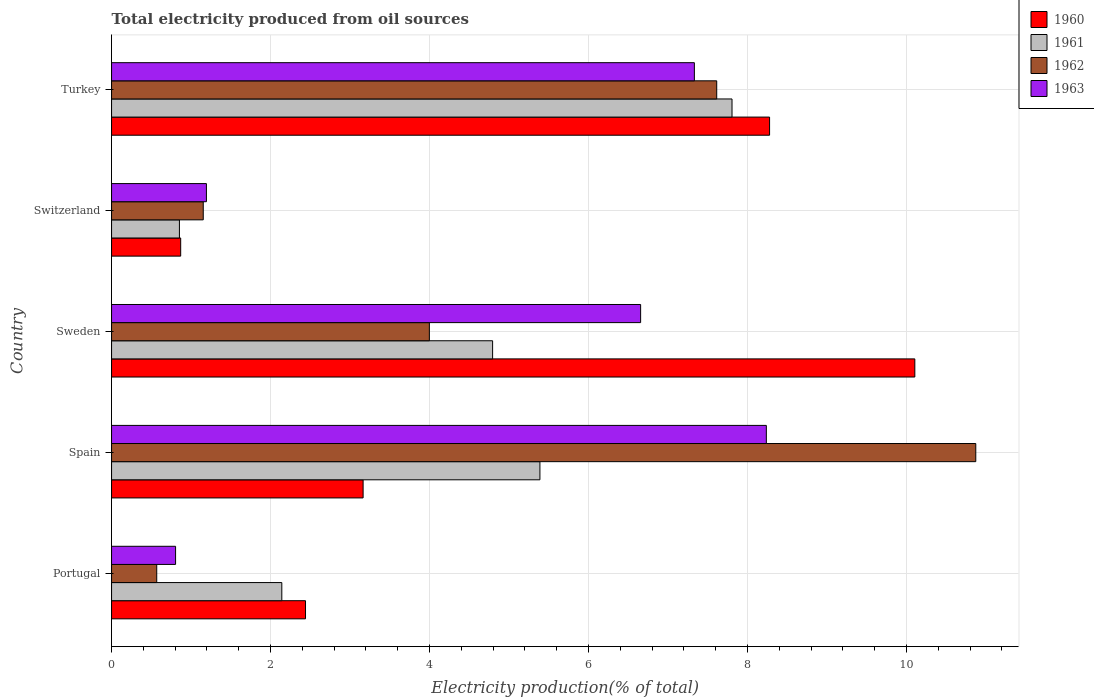How many different coloured bars are there?
Your answer should be compact. 4. Are the number of bars on each tick of the Y-axis equal?
Your answer should be compact. Yes. How many bars are there on the 5th tick from the top?
Your response must be concise. 4. What is the label of the 5th group of bars from the top?
Offer a very short reply. Portugal. In how many cases, is the number of bars for a given country not equal to the number of legend labels?
Provide a succinct answer. 0. What is the total electricity produced in 1961 in Spain?
Make the answer very short. 5.39. Across all countries, what is the maximum total electricity produced in 1963?
Ensure brevity in your answer.  8.24. Across all countries, what is the minimum total electricity produced in 1960?
Provide a short and direct response. 0.87. In which country was the total electricity produced in 1961 minimum?
Your answer should be compact. Switzerland. What is the total total electricity produced in 1963 in the graph?
Provide a short and direct response. 24.22. What is the difference between the total electricity produced in 1963 in Spain and that in Switzerland?
Give a very brief answer. 7.04. What is the difference between the total electricity produced in 1960 in Portugal and the total electricity produced in 1961 in Turkey?
Provide a short and direct response. -5.36. What is the average total electricity produced in 1960 per country?
Provide a succinct answer. 4.97. What is the difference between the total electricity produced in 1960 and total electricity produced in 1962 in Portugal?
Your answer should be very brief. 1.87. In how many countries, is the total electricity produced in 1960 greater than 5.6 %?
Your response must be concise. 2. What is the ratio of the total electricity produced in 1960 in Spain to that in Turkey?
Offer a very short reply. 0.38. Is the difference between the total electricity produced in 1960 in Spain and Switzerland greater than the difference between the total electricity produced in 1962 in Spain and Switzerland?
Your response must be concise. No. What is the difference between the highest and the second highest total electricity produced in 1960?
Provide a succinct answer. 1.83. What is the difference between the highest and the lowest total electricity produced in 1963?
Keep it short and to the point. 7.43. In how many countries, is the total electricity produced in 1960 greater than the average total electricity produced in 1960 taken over all countries?
Your answer should be compact. 2. Is the sum of the total electricity produced in 1961 in Spain and Turkey greater than the maximum total electricity produced in 1962 across all countries?
Your answer should be compact. Yes. What does the 3rd bar from the top in Spain represents?
Offer a terse response. 1961. What does the 1st bar from the bottom in Turkey represents?
Give a very brief answer. 1960. Are all the bars in the graph horizontal?
Make the answer very short. Yes. How many countries are there in the graph?
Offer a very short reply. 5. Where does the legend appear in the graph?
Give a very brief answer. Top right. What is the title of the graph?
Your answer should be compact. Total electricity produced from oil sources. What is the label or title of the X-axis?
Keep it short and to the point. Electricity production(% of total). What is the label or title of the Y-axis?
Offer a very short reply. Country. What is the Electricity production(% of total) of 1960 in Portugal?
Provide a short and direct response. 2.44. What is the Electricity production(% of total) in 1961 in Portugal?
Your answer should be very brief. 2.14. What is the Electricity production(% of total) in 1962 in Portugal?
Give a very brief answer. 0.57. What is the Electricity production(% of total) in 1963 in Portugal?
Offer a very short reply. 0.81. What is the Electricity production(% of total) in 1960 in Spain?
Provide a succinct answer. 3.16. What is the Electricity production(% of total) of 1961 in Spain?
Provide a succinct answer. 5.39. What is the Electricity production(% of total) of 1962 in Spain?
Provide a succinct answer. 10.87. What is the Electricity production(% of total) in 1963 in Spain?
Provide a short and direct response. 8.24. What is the Electricity production(% of total) in 1960 in Sweden?
Offer a very short reply. 10.1. What is the Electricity production(% of total) in 1961 in Sweden?
Your answer should be very brief. 4.79. What is the Electricity production(% of total) in 1962 in Sweden?
Offer a terse response. 4. What is the Electricity production(% of total) in 1963 in Sweden?
Give a very brief answer. 6.66. What is the Electricity production(% of total) in 1960 in Switzerland?
Your response must be concise. 0.87. What is the Electricity production(% of total) of 1961 in Switzerland?
Your response must be concise. 0.85. What is the Electricity production(% of total) of 1962 in Switzerland?
Provide a short and direct response. 1.15. What is the Electricity production(% of total) of 1963 in Switzerland?
Ensure brevity in your answer.  1.19. What is the Electricity production(% of total) in 1960 in Turkey?
Provide a short and direct response. 8.28. What is the Electricity production(% of total) in 1961 in Turkey?
Your answer should be very brief. 7.8. What is the Electricity production(% of total) in 1962 in Turkey?
Your answer should be compact. 7.61. What is the Electricity production(% of total) in 1963 in Turkey?
Keep it short and to the point. 7.33. Across all countries, what is the maximum Electricity production(% of total) in 1960?
Ensure brevity in your answer.  10.1. Across all countries, what is the maximum Electricity production(% of total) of 1961?
Offer a terse response. 7.8. Across all countries, what is the maximum Electricity production(% of total) in 1962?
Offer a terse response. 10.87. Across all countries, what is the maximum Electricity production(% of total) of 1963?
Provide a short and direct response. 8.24. Across all countries, what is the minimum Electricity production(% of total) in 1960?
Ensure brevity in your answer.  0.87. Across all countries, what is the minimum Electricity production(% of total) of 1961?
Your response must be concise. 0.85. Across all countries, what is the minimum Electricity production(% of total) in 1962?
Give a very brief answer. 0.57. Across all countries, what is the minimum Electricity production(% of total) of 1963?
Your answer should be compact. 0.81. What is the total Electricity production(% of total) in 1960 in the graph?
Provide a succinct answer. 24.85. What is the total Electricity production(% of total) of 1961 in the graph?
Ensure brevity in your answer.  20.98. What is the total Electricity production(% of total) in 1962 in the graph?
Your answer should be compact. 24.2. What is the total Electricity production(% of total) in 1963 in the graph?
Your response must be concise. 24.22. What is the difference between the Electricity production(% of total) of 1960 in Portugal and that in Spain?
Offer a very short reply. -0.72. What is the difference between the Electricity production(% of total) of 1961 in Portugal and that in Spain?
Ensure brevity in your answer.  -3.25. What is the difference between the Electricity production(% of total) in 1962 in Portugal and that in Spain?
Your response must be concise. -10.3. What is the difference between the Electricity production(% of total) of 1963 in Portugal and that in Spain?
Your answer should be very brief. -7.43. What is the difference between the Electricity production(% of total) of 1960 in Portugal and that in Sweden?
Provide a short and direct response. -7.66. What is the difference between the Electricity production(% of total) in 1961 in Portugal and that in Sweden?
Give a very brief answer. -2.65. What is the difference between the Electricity production(% of total) of 1962 in Portugal and that in Sweden?
Offer a terse response. -3.43. What is the difference between the Electricity production(% of total) of 1963 in Portugal and that in Sweden?
Provide a short and direct response. -5.85. What is the difference between the Electricity production(% of total) in 1960 in Portugal and that in Switzerland?
Give a very brief answer. 1.57. What is the difference between the Electricity production(% of total) of 1961 in Portugal and that in Switzerland?
Keep it short and to the point. 1.29. What is the difference between the Electricity production(% of total) in 1962 in Portugal and that in Switzerland?
Make the answer very short. -0.59. What is the difference between the Electricity production(% of total) of 1963 in Portugal and that in Switzerland?
Keep it short and to the point. -0.39. What is the difference between the Electricity production(% of total) in 1960 in Portugal and that in Turkey?
Your answer should be compact. -5.84. What is the difference between the Electricity production(% of total) of 1961 in Portugal and that in Turkey?
Your response must be concise. -5.66. What is the difference between the Electricity production(% of total) of 1962 in Portugal and that in Turkey?
Give a very brief answer. -7.04. What is the difference between the Electricity production(% of total) in 1963 in Portugal and that in Turkey?
Provide a succinct answer. -6.53. What is the difference between the Electricity production(% of total) of 1960 in Spain and that in Sweden?
Offer a terse response. -6.94. What is the difference between the Electricity production(% of total) in 1961 in Spain and that in Sweden?
Your response must be concise. 0.6. What is the difference between the Electricity production(% of total) in 1962 in Spain and that in Sweden?
Keep it short and to the point. 6.87. What is the difference between the Electricity production(% of total) of 1963 in Spain and that in Sweden?
Provide a short and direct response. 1.58. What is the difference between the Electricity production(% of total) in 1960 in Spain and that in Switzerland?
Your answer should be very brief. 2.29. What is the difference between the Electricity production(% of total) of 1961 in Spain and that in Switzerland?
Your answer should be very brief. 4.53. What is the difference between the Electricity production(% of total) of 1962 in Spain and that in Switzerland?
Give a very brief answer. 9.72. What is the difference between the Electricity production(% of total) in 1963 in Spain and that in Switzerland?
Provide a short and direct response. 7.04. What is the difference between the Electricity production(% of total) of 1960 in Spain and that in Turkey?
Keep it short and to the point. -5.11. What is the difference between the Electricity production(% of total) of 1961 in Spain and that in Turkey?
Offer a terse response. -2.42. What is the difference between the Electricity production(% of total) in 1962 in Spain and that in Turkey?
Offer a very short reply. 3.26. What is the difference between the Electricity production(% of total) of 1963 in Spain and that in Turkey?
Your answer should be compact. 0.91. What is the difference between the Electricity production(% of total) of 1960 in Sweden and that in Switzerland?
Provide a short and direct response. 9.23. What is the difference between the Electricity production(% of total) of 1961 in Sweden and that in Switzerland?
Offer a very short reply. 3.94. What is the difference between the Electricity production(% of total) of 1962 in Sweden and that in Switzerland?
Provide a succinct answer. 2.84. What is the difference between the Electricity production(% of total) of 1963 in Sweden and that in Switzerland?
Ensure brevity in your answer.  5.46. What is the difference between the Electricity production(% of total) of 1960 in Sweden and that in Turkey?
Your response must be concise. 1.83. What is the difference between the Electricity production(% of total) of 1961 in Sweden and that in Turkey?
Provide a succinct answer. -3.01. What is the difference between the Electricity production(% of total) in 1962 in Sweden and that in Turkey?
Offer a terse response. -3.61. What is the difference between the Electricity production(% of total) of 1963 in Sweden and that in Turkey?
Offer a very short reply. -0.68. What is the difference between the Electricity production(% of total) in 1960 in Switzerland and that in Turkey?
Give a very brief answer. -7.41. What is the difference between the Electricity production(% of total) of 1961 in Switzerland and that in Turkey?
Give a very brief answer. -6.95. What is the difference between the Electricity production(% of total) in 1962 in Switzerland and that in Turkey?
Your answer should be very brief. -6.46. What is the difference between the Electricity production(% of total) of 1963 in Switzerland and that in Turkey?
Keep it short and to the point. -6.14. What is the difference between the Electricity production(% of total) of 1960 in Portugal and the Electricity production(% of total) of 1961 in Spain?
Offer a very short reply. -2.95. What is the difference between the Electricity production(% of total) in 1960 in Portugal and the Electricity production(% of total) in 1962 in Spain?
Make the answer very short. -8.43. What is the difference between the Electricity production(% of total) of 1960 in Portugal and the Electricity production(% of total) of 1963 in Spain?
Give a very brief answer. -5.8. What is the difference between the Electricity production(% of total) in 1961 in Portugal and the Electricity production(% of total) in 1962 in Spain?
Your response must be concise. -8.73. What is the difference between the Electricity production(% of total) in 1961 in Portugal and the Electricity production(% of total) in 1963 in Spain?
Give a very brief answer. -6.09. What is the difference between the Electricity production(% of total) in 1962 in Portugal and the Electricity production(% of total) in 1963 in Spain?
Give a very brief answer. -7.67. What is the difference between the Electricity production(% of total) of 1960 in Portugal and the Electricity production(% of total) of 1961 in Sweden?
Your answer should be compact. -2.35. What is the difference between the Electricity production(% of total) of 1960 in Portugal and the Electricity production(% of total) of 1962 in Sweden?
Give a very brief answer. -1.56. What is the difference between the Electricity production(% of total) of 1960 in Portugal and the Electricity production(% of total) of 1963 in Sweden?
Provide a succinct answer. -4.22. What is the difference between the Electricity production(% of total) of 1961 in Portugal and the Electricity production(% of total) of 1962 in Sweden?
Offer a terse response. -1.86. What is the difference between the Electricity production(% of total) of 1961 in Portugal and the Electricity production(% of total) of 1963 in Sweden?
Offer a terse response. -4.51. What is the difference between the Electricity production(% of total) in 1962 in Portugal and the Electricity production(% of total) in 1963 in Sweden?
Provide a succinct answer. -6.09. What is the difference between the Electricity production(% of total) of 1960 in Portugal and the Electricity production(% of total) of 1961 in Switzerland?
Keep it short and to the point. 1.59. What is the difference between the Electricity production(% of total) in 1960 in Portugal and the Electricity production(% of total) in 1962 in Switzerland?
Provide a short and direct response. 1.29. What is the difference between the Electricity production(% of total) of 1960 in Portugal and the Electricity production(% of total) of 1963 in Switzerland?
Make the answer very short. 1.25. What is the difference between the Electricity production(% of total) in 1961 in Portugal and the Electricity production(% of total) in 1962 in Switzerland?
Keep it short and to the point. 0.99. What is the difference between the Electricity production(% of total) in 1961 in Portugal and the Electricity production(% of total) in 1963 in Switzerland?
Provide a short and direct response. 0.95. What is the difference between the Electricity production(% of total) of 1962 in Portugal and the Electricity production(% of total) of 1963 in Switzerland?
Offer a very short reply. -0.63. What is the difference between the Electricity production(% of total) in 1960 in Portugal and the Electricity production(% of total) in 1961 in Turkey?
Provide a succinct answer. -5.36. What is the difference between the Electricity production(% of total) of 1960 in Portugal and the Electricity production(% of total) of 1962 in Turkey?
Provide a short and direct response. -5.17. What is the difference between the Electricity production(% of total) of 1960 in Portugal and the Electricity production(% of total) of 1963 in Turkey?
Give a very brief answer. -4.89. What is the difference between the Electricity production(% of total) in 1961 in Portugal and the Electricity production(% of total) in 1962 in Turkey?
Provide a succinct answer. -5.47. What is the difference between the Electricity production(% of total) of 1961 in Portugal and the Electricity production(% of total) of 1963 in Turkey?
Your response must be concise. -5.19. What is the difference between the Electricity production(% of total) in 1962 in Portugal and the Electricity production(% of total) in 1963 in Turkey?
Your response must be concise. -6.76. What is the difference between the Electricity production(% of total) of 1960 in Spain and the Electricity production(% of total) of 1961 in Sweden?
Keep it short and to the point. -1.63. What is the difference between the Electricity production(% of total) of 1960 in Spain and the Electricity production(% of total) of 1963 in Sweden?
Make the answer very short. -3.49. What is the difference between the Electricity production(% of total) of 1961 in Spain and the Electricity production(% of total) of 1962 in Sweden?
Your answer should be very brief. 1.39. What is the difference between the Electricity production(% of total) of 1961 in Spain and the Electricity production(% of total) of 1963 in Sweden?
Provide a succinct answer. -1.27. What is the difference between the Electricity production(% of total) of 1962 in Spain and the Electricity production(% of total) of 1963 in Sweden?
Your response must be concise. 4.22. What is the difference between the Electricity production(% of total) in 1960 in Spain and the Electricity production(% of total) in 1961 in Switzerland?
Provide a succinct answer. 2.31. What is the difference between the Electricity production(% of total) of 1960 in Spain and the Electricity production(% of total) of 1962 in Switzerland?
Your answer should be very brief. 2.01. What is the difference between the Electricity production(% of total) of 1960 in Spain and the Electricity production(% of total) of 1963 in Switzerland?
Provide a succinct answer. 1.97. What is the difference between the Electricity production(% of total) in 1961 in Spain and the Electricity production(% of total) in 1962 in Switzerland?
Your response must be concise. 4.24. What is the difference between the Electricity production(% of total) in 1961 in Spain and the Electricity production(% of total) in 1963 in Switzerland?
Offer a very short reply. 4.2. What is the difference between the Electricity production(% of total) in 1962 in Spain and the Electricity production(% of total) in 1963 in Switzerland?
Your answer should be compact. 9.68. What is the difference between the Electricity production(% of total) in 1960 in Spain and the Electricity production(% of total) in 1961 in Turkey?
Make the answer very short. -4.64. What is the difference between the Electricity production(% of total) of 1960 in Spain and the Electricity production(% of total) of 1962 in Turkey?
Your answer should be compact. -4.45. What is the difference between the Electricity production(% of total) in 1960 in Spain and the Electricity production(% of total) in 1963 in Turkey?
Your answer should be very brief. -4.17. What is the difference between the Electricity production(% of total) in 1961 in Spain and the Electricity production(% of total) in 1962 in Turkey?
Offer a very short reply. -2.22. What is the difference between the Electricity production(% of total) in 1961 in Spain and the Electricity production(% of total) in 1963 in Turkey?
Ensure brevity in your answer.  -1.94. What is the difference between the Electricity production(% of total) in 1962 in Spain and the Electricity production(% of total) in 1963 in Turkey?
Give a very brief answer. 3.54. What is the difference between the Electricity production(% of total) in 1960 in Sweden and the Electricity production(% of total) in 1961 in Switzerland?
Ensure brevity in your answer.  9.25. What is the difference between the Electricity production(% of total) in 1960 in Sweden and the Electricity production(% of total) in 1962 in Switzerland?
Ensure brevity in your answer.  8.95. What is the difference between the Electricity production(% of total) in 1960 in Sweden and the Electricity production(% of total) in 1963 in Switzerland?
Offer a very short reply. 8.91. What is the difference between the Electricity production(% of total) in 1961 in Sweden and the Electricity production(% of total) in 1962 in Switzerland?
Your response must be concise. 3.64. What is the difference between the Electricity production(% of total) of 1961 in Sweden and the Electricity production(% of total) of 1963 in Switzerland?
Give a very brief answer. 3.6. What is the difference between the Electricity production(% of total) in 1962 in Sweden and the Electricity production(% of total) in 1963 in Switzerland?
Give a very brief answer. 2.8. What is the difference between the Electricity production(% of total) in 1960 in Sweden and the Electricity production(% of total) in 1961 in Turkey?
Ensure brevity in your answer.  2.3. What is the difference between the Electricity production(% of total) of 1960 in Sweden and the Electricity production(% of total) of 1962 in Turkey?
Offer a very short reply. 2.49. What is the difference between the Electricity production(% of total) in 1960 in Sweden and the Electricity production(% of total) in 1963 in Turkey?
Ensure brevity in your answer.  2.77. What is the difference between the Electricity production(% of total) in 1961 in Sweden and the Electricity production(% of total) in 1962 in Turkey?
Give a very brief answer. -2.82. What is the difference between the Electricity production(% of total) of 1961 in Sweden and the Electricity production(% of total) of 1963 in Turkey?
Keep it short and to the point. -2.54. What is the difference between the Electricity production(% of total) of 1962 in Sweden and the Electricity production(% of total) of 1963 in Turkey?
Keep it short and to the point. -3.33. What is the difference between the Electricity production(% of total) of 1960 in Switzerland and the Electricity production(% of total) of 1961 in Turkey?
Offer a terse response. -6.94. What is the difference between the Electricity production(% of total) in 1960 in Switzerland and the Electricity production(% of total) in 1962 in Turkey?
Your answer should be very brief. -6.74. What is the difference between the Electricity production(% of total) of 1960 in Switzerland and the Electricity production(% of total) of 1963 in Turkey?
Ensure brevity in your answer.  -6.46. What is the difference between the Electricity production(% of total) in 1961 in Switzerland and the Electricity production(% of total) in 1962 in Turkey?
Keep it short and to the point. -6.76. What is the difference between the Electricity production(% of total) in 1961 in Switzerland and the Electricity production(% of total) in 1963 in Turkey?
Offer a very short reply. -6.48. What is the difference between the Electricity production(% of total) in 1962 in Switzerland and the Electricity production(% of total) in 1963 in Turkey?
Your answer should be compact. -6.18. What is the average Electricity production(% of total) of 1960 per country?
Provide a succinct answer. 4.97. What is the average Electricity production(% of total) of 1961 per country?
Provide a succinct answer. 4.2. What is the average Electricity production(% of total) in 1962 per country?
Keep it short and to the point. 4.84. What is the average Electricity production(% of total) of 1963 per country?
Your response must be concise. 4.84. What is the difference between the Electricity production(% of total) in 1960 and Electricity production(% of total) in 1961 in Portugal?
Your answer should be compact. 0.3. What is the difference between the Electricity production(% of total) in 1960 and Electricity production(% of total) in 1962 in Portugal?
Provide a succinct answer. 1.87. What is the difference between the Electricity production(% of total) in 1960 and Electricity production(% of total) in 1963 in Portugal?
Your response must be concise. 1.63. What is the difference between the Electricity production(% of total) in 1961 and Electricity production(% of total) in 1962 in Portugal?
Provide a short and direct response. 1.57. What is the difference between the Electricity production(% of total) of 1961 and Electricity production(% of total) of 1963 in Portugal?
Provide a short and direct response. 1.34. What is the difference between the Electricity production(% of total) of 1962 and Electricity production(% of total) of 1963 in Portugal?
Your answer should be compact. -0.24. What is the difference between the Electricity production(% of total) of 1960 and Electricity production(% of total) of 1961 in Spain?
Offer a terse response. -2.22. What is the difference between the Electricity production(% of total) of 1960 and Electricity production(% of total) of 1962 in Spain?
Give a very brief answer. -7.71. What is the difference between the Electricity production(% of total) in 1960 and Electricity production(% of total) in 1963 in Spain?
Make the answer very short. -5.07. What is the difference between the Electricity production(% of total) in 1961 and Electricity production(% of total) in 1962 in Spain?
Your answer should be very brief. -5.48. What is the difference between the Electricity production(% of total) of 1961 and Electricity production(% of total) of 1963 in Spain?
Your response must be concise. -2.85. What is the difference between the Electricity production(% of total) of 1962 and Electricity production(% of total) of 1963 in Spain?
Provide a short and direct response. 2.63. What is the difference between the Electricity production(% of total) of 1960 and Electricity production(% of total) of 1961 in Sweden?
Provide a succinct answer. 5.31. What is the difference between the Electricity production(% of total) in 1960 and Electricity production(% of total) in 1962 in Sweden?
Ensure brevity in your answer.  6.11. What is the difference between the Electricity production(% of total) of 1960 and Electricity production(% of total) of 1963 in Sweden?
Your answer should be very brief. 3.45. What is the difference between the Electricity production(% of total) of 1961 and Electricity production(% of total) of 1962 in Sweden?
Offer a terse response. 0.8. What is the difference between the Electricity production(% of total) of 1961 and Electricity production(% of total) of 1963 in Sweden?
Give a very brief answer. -1.86. What is the difference between the Electricity production(% of total) in 1962 and Electricity production(% of total) in 1963 in Sweden?
Make the answer very short. -2.66. What is the difference between the Electricity production(% of total) in 1960 and Electricity production(% of total) in 1961 in Switzerland?
Give a very brief answer. 0.02. What is the difference between the Electricity production(% of total) in 1960 and Electricity production(% of total) in 1962 in Switzerland?
Ensure brevity in your answer.  -0.28. What is the difference between the Electricity production(% of total) of 1960 and Electricity production(% of total) of 1963 in Switzerland?
Provide a short and direct response. -0.32. What is the difference between the Electricity production(% of total) of 1961 and Electricity production(% of total) of 1962 in Switzerland?
Make the answer very short. -0.3. What is the difference between the Electricity production(% of total) of 1961 and Electricity production(% of total) of 1963 in Switzerland?
Provide a succinct answer. -0.34. What is the difference between the Electricity production(% of total) of 1962 and Electricity production(% of total) of 1963 in Switzerland?
Your answer should be very brief. -0.04. What is the difference between the Electricity production(% of total) of 1960 and Electricity production(% of total) of 1961 in Turkey?
Offer a terse response. 0.47. What is the difference between the Electricity production(% of total) in 1960 and Electricity production(% of total) in 1962 in Turkey?
Keep it short and to the point. 0.66. What is the difference between the Electricity production(% of total) of 1960 and Electricity production(% of total) of 1963 in Turkey?
Offer a terse response. 0.95. What is the difference between the Electricity production(% of total) in 1961 and Electricity production(% of total) in 1962 in Turkey?
Make the answer very short. 0.19. What is the difference between the Electricity production(% of total) in 1961 and Electricity production(% of total) in 1963 in Turkey?
Give a very brief answer. 0.47. What is the difference between the Electricity production(% of total) of 1962 and Electricity production(% of total) of 1963 in Turkey?
Keep it short and to the point. 0.28. What is the ratio of the Electricity production(% of total) of 1960 in Portugal to that in Spain?
Give a very brief answer. 0.77. What is the ratio of the Electricity production(% of total) of 1961 in Portugal to that in Spain?
Make the answer very short. 0.4. What is the ratio of the Electricity production(% of total) of 1962 in Portugal to that in Spain?
Provide a short and direct response. 0.05. What is the ratio of the Electricity production(% of total) of 1963 in Portugal to that in Spain?
Offer a terse response. 0.1. What is the ratio of the Electricity production(% of total) in 1960 in Portugal to that in Sweden?
Your answer should be compact. 0.24. What is the ratio of the Electricity production(% of total) in 1961 in Portugal to that in Sweden?
Offer a very short reply. 0.45. What is the ratio of the Electricity production(% of total) of 1962 in Portugal to that in Sweden?
Keep it short and to the point. 0.14. What is the ratio of the Electricity production(% of total) of 1963 in Portugal to that in Sweden?
Your answer should be compact. 0.12. What is the ratio of the Electricity production(% of total) in 1960 in Portugal to that in Switzerland?
Offer a very short reply. 2.81. What is the ratio of the Electricity production(% of total) in 1961 in Portugal to that in Switzerland?
Give a very brief answer. 2.51. What is the ratio of the Electricity production(% of total) in 1962 in Portugal to that in Switzerland?
Provide a short and direct response. 0.49. What is the ratio of the Electricity production(% of total) of 1963 in Portugal to that in Switzerland?
Your response must be concise. 0.67. What is the ratio of the Electricity production(% of total) in 1960 in Portugal to that in Turkey?
Keep it short and to the point. 0.29. What is the ratio of the Electricity production(% of total) in 1961 in Portugal to that in Turkey?
Provide a succinct answer. 0.27. What is the ratio of the Electricity production(% of total) in 1962 in Portugal to that in Turkey?
Your answer should be very brief. 0.07. What is the ratio of the Electricity production(% of total) in 1963 in Portugal to that in Turkey?
Give a very brief answer. 0.11. What is the ratio of the Electricity production(% of total) of 1960 in Spain to that in Sweden?
Ensure brevity in your answer.  0.31. What is the ratio of the Electricity production(% of total) of 1961 in Spain to that in Sweden?
Keep it short and to the point. 1.12. What is the ratio of the Electricity production(% of total) in 1962 in Spain to that in Sweden?
Ensure brevity in your answer.  2.72. What is the ratio of the Electricity production(% of total) in 1963 in Spain to that in Sweden?
Your answer should be very brief. 1.24. What is the ratio of the Electricity production(% of total) in 1960 in Spain to that in Switzerland?
Give a very brief answer. 3.64. What is the ratio of the Electricity production(% of total) in 1961 in Spain to that in Switzerland?
Keep it short and to the point. 6.31. What is the ratio of the Electricity production(% of total) in 1962 in Spain to that in Switzerland?
Your answer should be compact. 9.43. What is the ratio of the Electricity production(% of total) in 1963 in Spain to that in Switzerland?
Make the answer very short. 6.9. What is the ratio of the Electricity production(% of total) of 1960 in Spain to that in Turkey?
Keep it short and to the point. 0.38. What is the ratio of the Electricity production(% of total) of 1961 in Spain to that in Turkey?
Offer a very short reply. 0.69. What is the ratio of the Electricity production(% of total) in 1962 in Spain to that in Turkey?
Provide a short and direct response. 1.43. What is the ratio of the Electricity production(% of total) of 1963 in Spain to that in Turkey?
Keep it short and to the point. 1.12. What is the ratio of the Electricity production(% of total) in 1960 in Sweden to that in Switzerland?
Your answer should be compact. 11.62. What is the ratio of the Electricity production(% of total) in 1961 in Sweden to that in Switzerland?
Offer a terse response. 5.62. What is the ratio of the Electricity production(% of total) in 1962 in Sweden to that in Switzerland?
Make the answer very short. 3.47. What is the ratio of the Electricity production(% of total) of 1963 in Sweden to that in Switzerland?
Provide a short and direct response. 5.58. What is the ratio of the Electricity production(% of total) of 1960 in Sweden to that in Turkey?
Give a very brief answer. 1.22. What is the ratio of the Electricity production(% of total) of 1961 in Sweden to that in Turkey?
Give a very brief answer. 0.61. What is the ratio of the Electricity production(% of total) in 1962 in Sweden to that in Turkey?
Offer a very short reply. 0.53. What is the ratio of the Electricity production(% of total) in 1963 in Sweden to that in Turkey?
Provide a succinct answer. 0.91. What is the ratio of the Electricity production(% of total) in 1960 in Switzerland to that in Turkey?
Provide a succinct answer. 0.11. What is the ratio of the Electricity production(% of total) of 1961 in Switzerland to that in Turkey?
Your answer should be very brief. 0.11. What is the ratio of the Electricity production(% of total) of 1962 in Switzerland to that in Turkey?
Provide a short and direct response. 0.15. What is the ratio of the Electricity production(% of total) in 1963 in Switzerland to that in Turkey?
Offer a very short reply. 0.16. What is the difference between the highest and the second highest Electricity production(% of total) of 1960?
Make the answer very short. 1.83. What is the difference between the highest and the second highest Electricity production(% of total) in 1961?
Your response must be concise. 2.42. What is the difference between the highest and the second highest Electricity production(% of total) in 1962?
Keep it short and to the point. 3.26. What is the difference between the highest and the second highest Electricity production(% of total) of 1963?
Provide a succinct answer. 0.91. What is the difference between the highest and the lowest Electricity production(% of total) of 1960?
Ensure brevity in your answer.  9.23. What is the difference between the highest and the lowest Electricity production(% of total) of 1961?
Offer a very short reply. 6.95. What is the difference between the highest and the lowest Electricity production(% of total) of 1962?
Keep it short and to the point. 10.3. What is the difference between the highest and the lowest Electricity production(% of total) of 1963?
Keep it short and to the point. 7.43. 